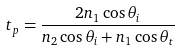<formula> <loc_0><loc_0><loc_500><loc_500>t _ { p } = { \frac { 2 n _ { 1 } \cos \theta _ { i } } { n _ { 2 } \cos \theta _ { i } + n _ { 1 } \cos \theta _ { t } } }</formula> 